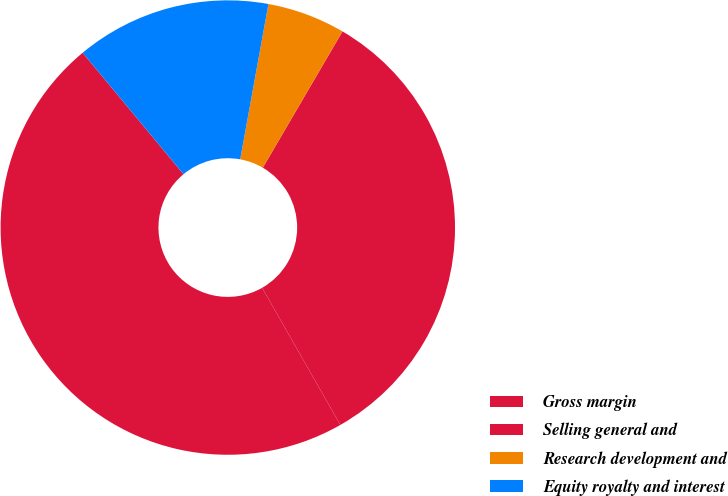Convert chart to OTSL. <chart><loc_0><loc_0><loc_500><loc_500><pie_chart><fcel>Gross margin<fcel>Selling general and<fcel>Research development and<fcel>Equity royalty and interest<nl><fcel>47.22%<fcel>33.33%<fcel>5.56%<fcel>13.89%<nl></chart> 